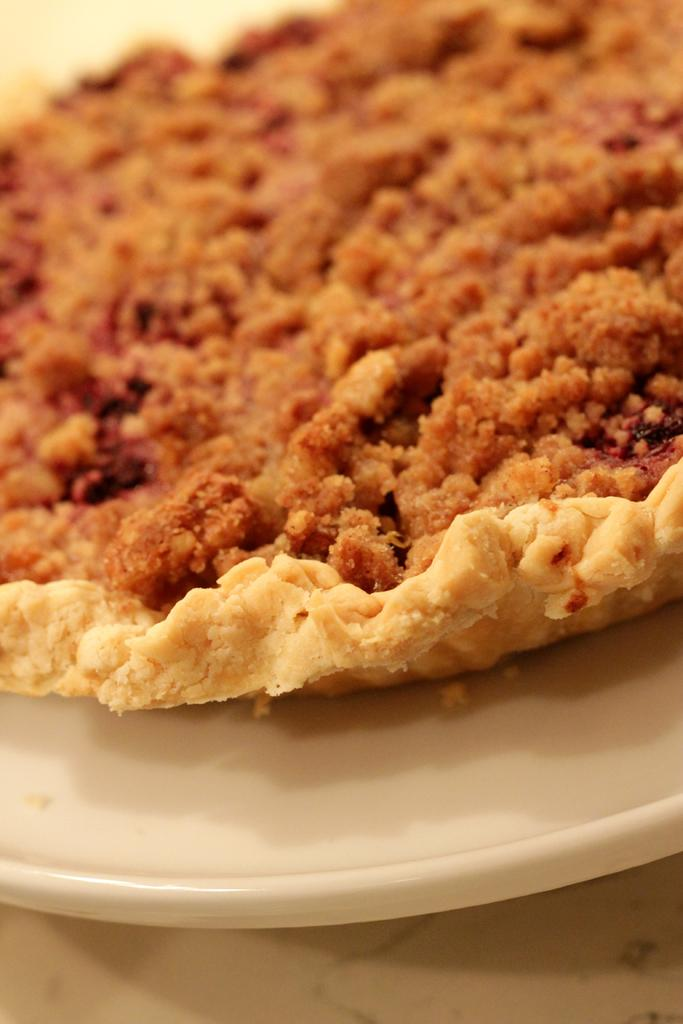What is the main subject of the image? The main subject of the image is a food item on a white plate. Can you describe the appearance of the food item? The food has brown and cream colors. What type of drug is being delivered in the parcel shown in the image? There is no parcel or drug present in the image; it only features a food item on a white plate. 